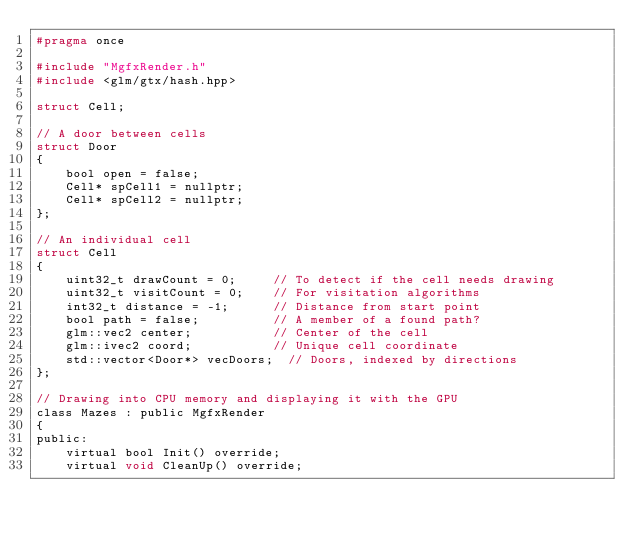<code> <loc_0><loc_0><loc_500><loc_500><_C_>#pragma once

#include "MgfxRender.h"
#include <glm/gtx/hash.hpp>

struct Cell;

// A door between cells
struct Door
{
    bool open = false;
    Cell* spCell1 = nullptr;
    Cell* spCell2 = nullptr;
};

// An individual cell
struct Cell
{
    uint32_t drawCount = 0;     // To detect if the cell needs drawing
    uint32_t visitCount = 0;    // For visitation algorithms
    int32_t distance = -1;      // Distance from start point
    bool path = false;          // A member of a found path?
    glm::vec2 center;           // Center of the cell
    glm::ivec2 coord;           // Unique cell coordinate
    std::vector<Door*> vecDoors;  // Doors, indexed by directions
};

// Drawing into CPU memory and displaying it with the GPU
class Mazes : public MgfxRender
{
public:
    virtual bool Init() override;
    virtual void CleanUp() override;</code> 